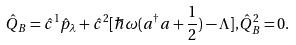Convert formula to latex. <formula><loc_0><loc_0><loc_500><loc_500>\hat { Q } _ { B } = \hat { c } ^ { 1 } \hat { p } _ { \lambda } + \hat { c } ^ { 2 } [ \hbar { \omega } ( a ^ { \dagger } a + \frac { 1 } { 2 } ) - \Lambda ] , \hat { Q } _ { B } ^ { 2 } = 0 .</formula> 